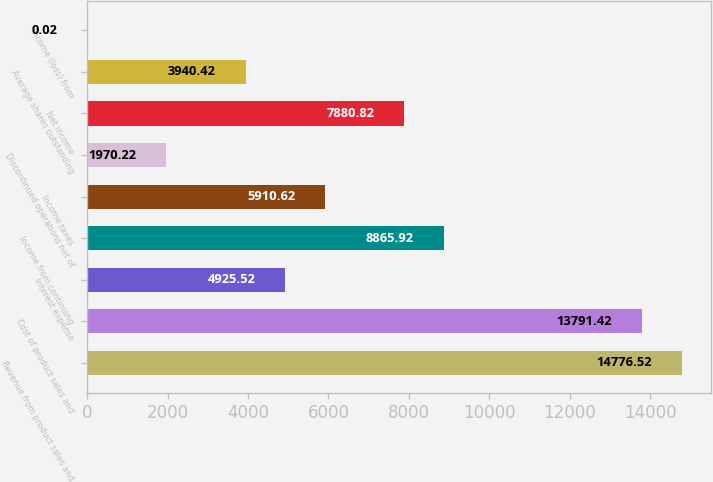<chart> <loc_0><loc_0><loc_500><loc_500><bar_chart><fcel>Revenue from product sales and<fcel>Cost of product sales and<fcel>Interest expense<fcel>Income from continuing<fcel>Income taxes<fcel>Discontinued operations net of<fcel>Net income<fcel>Average shares outstanding<fcel>Income (loss) from<nl><fcel>14776.5<fcel>13791.4<fcel>4925.52<fcel>8865.92<fcel>5910.62<fcel>1970.22<fcel>7880.82<fcel>3940.42<fcel>0.02<nl></chart> 